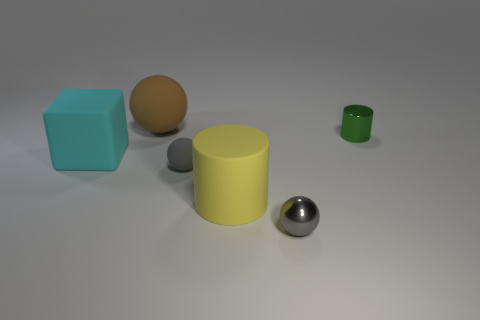Add 3 yellow metallic cylinders. How many objects exist? 9 Subtract all cubes. How many objects are left? 5 Subtract 1 yellow cylinders. How many objects are left? 5 Subtract all big cylinders. Subtract all yellow cylinders. How many objects are left? 4 Add 3 large yellow matte things. How many large yellow matte things are left? 4 Add 4 cubes. How many cubes exist? 5 